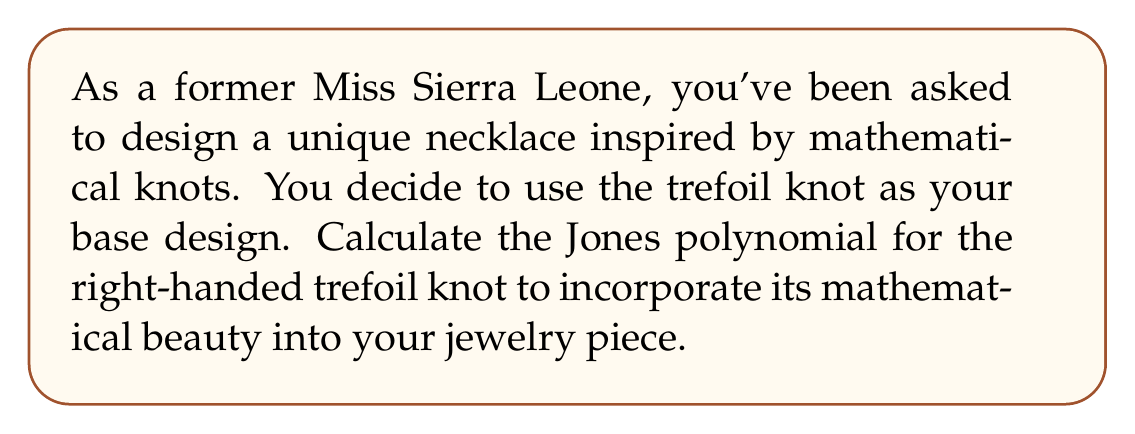Can you answer this question? Let's calculate the Jones polynomial for the right-handed trefoil knot step-by-step:

1) First, we need to create the Kauffman bracket polynomial. For the trefoil knot, we have:

   $$\langle K \rangle = A^7(-A^2-A^{-2})^3 + A^3(-A^2-A^{-2})^2$$

2) Next, we normalize this bracket polynomial by multiplying it by $(-A^3)^{-w(K)}$, where $w(K)$ is the writhe of the knot. For a right-handed trefoil, $w(K) = 3$.

3) The Jones polynomial $V_K(t)$ is obtained by substituting $A = t^{-1/4}$ in the normalized Kauffman bracket.

4) Let's expand the Kauffman bracket:

   $$\langle K \rangle = A^7(-A^2-A^{-2})^3 + A^3(-A^2-A^{-2})^2$$
   $$= A^7(-A^2-A^{-2})^3 + A^3(-A^2-A^{-2})^2$$
   $$= A^7(-A^2-A^{-2})(-A^2-A^{-2})(-A^2-A^{-2}) + A^3(-A^2-A^{-2})(-A^2-A^{-2})$$
   $$= A^7(-A^4-2+A^{-4}) + A^3(A^4+2+A^{-4})$$
   $$= -A^{11} - 2A^7 - A^3 + A^7 + 2A^3 + A^{-1}$$
   $$= -A^{11} - A^7 + A^3 + A^{-1}$$

5) Now, we normalize:

   $$(-A^3)^{-3}(-A^{11} - A^7 + A^3 + A^{-1})$$
   $$= (-A^{-9})(-A^{11} - A^7 + A^3 + A^{-1})$$
   $$= A^2 + A^{-2} - A^{-6} - A^{-10}$$

6) Finally, we substitute $A = t^{-1/4}$:

   $$V_K(t) = (t^{-1/4})^2 + (t^{-1/4})^{-2} - (t^{-1/4})^{-6} - (t^{-1/4})^{-10}$$
   $$= t^{-1/2} + t^{1/2} - t^{3/2} - t^{5/2}$$
Answer: $V_K(t) = t^{-1/2} + t^{1/2} - t^{3/2} - t^{5/2}$ 